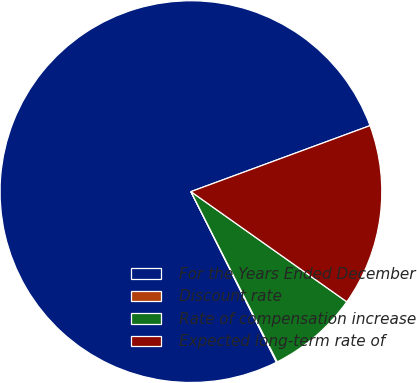Convert chart. <chart><loc_0><loc_0><loc_500><loc_500><pie_chart><fcel>For the Years Ended December<fcel>Discount rate<fcel>Rate of compensation increase<fcel>Expected long-term rate of<nl><fcel>76.77%<fcel>0.07%<fcel>7.74%<fcel>15.41%<nl></chart> 